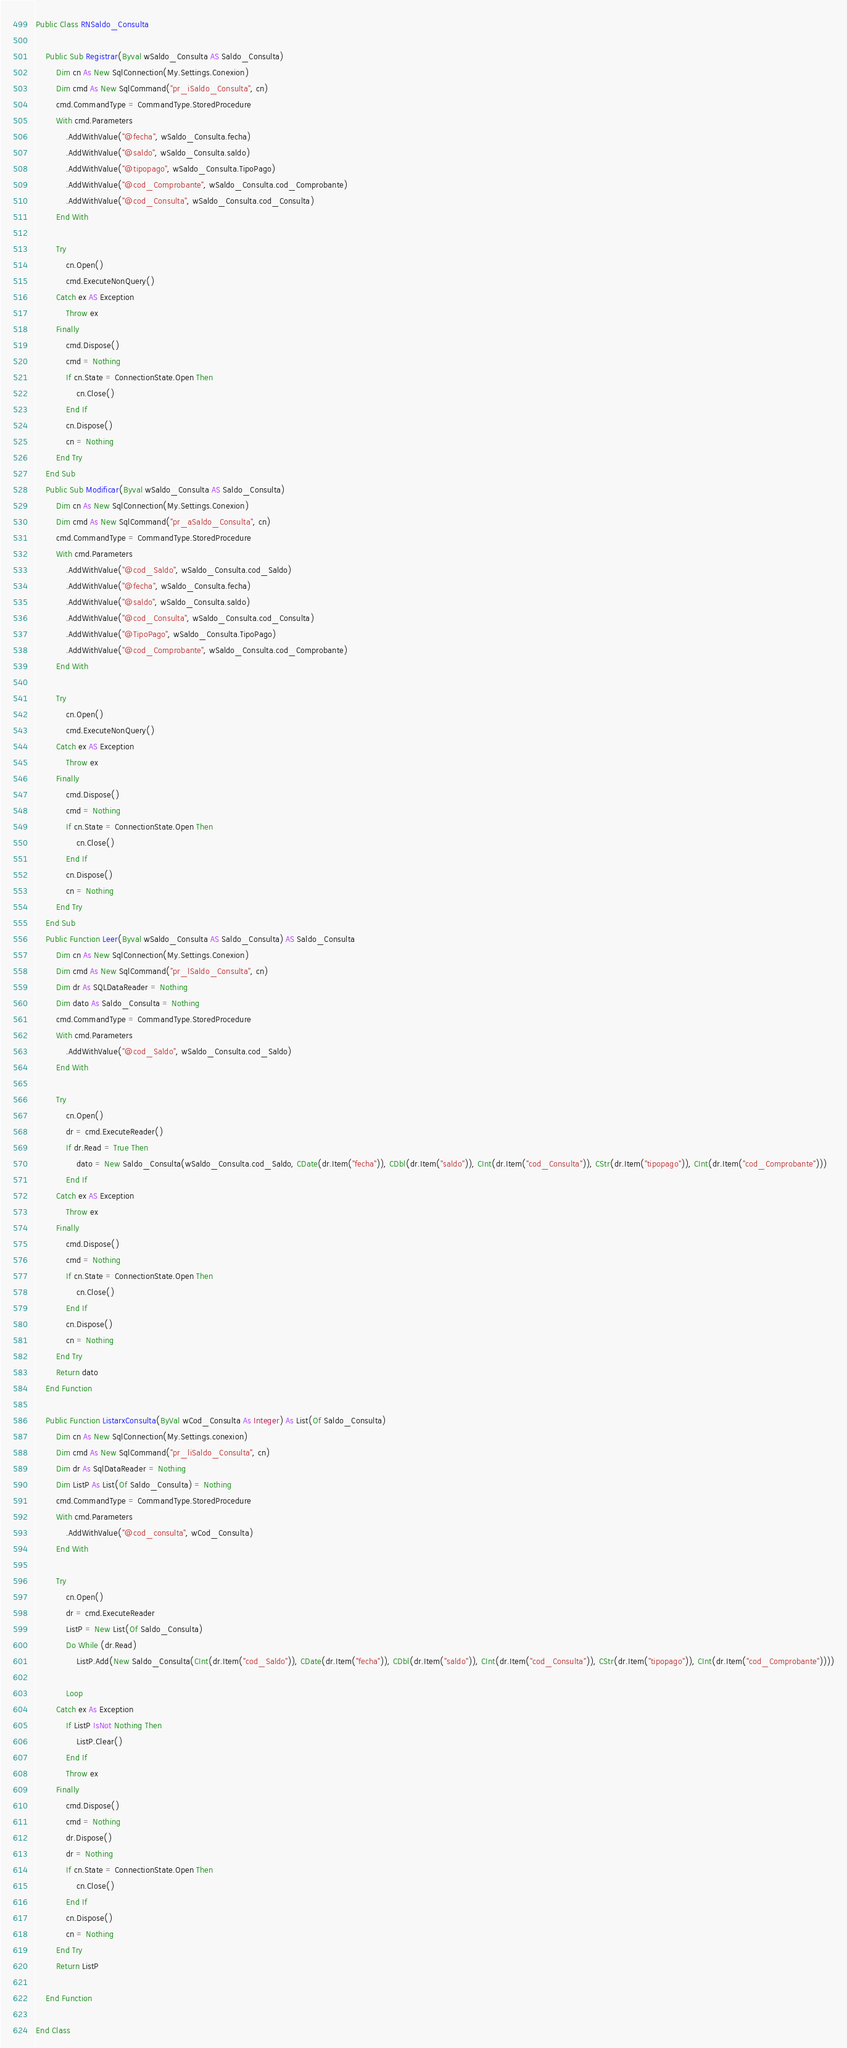<code> <loc_0><loc_0><loc_500><loc_500><_VisualBasic_>Public Class RNSaldo_Consulta

	Public Sub Registrar(Byval wSaldo_Consulta AS Saldo_Consulta)
		Dim cn As New SqlConnection(My.Settings.Conexion)
		Dim cmd As New SqlCommand("pr_iSaldo_Consulta", cn)
		cmd.CommandType = CommandType.StoredProcedure
		With cmd.Parameters
			.AddWithValue("@fecha", wSaldo_Consulta.fecha)
            .AddWithValue("@saldo", wSaldo_Consulta.saldo)
            .AddWithValue("@tipopago", wSaldo_Consulta.TipoPago)
            .AddWithValue("@cod_Comprobante", wSaldo_Consulta.cod_Comprobante)
            .AddWithValue("@cod_Consulta", wSaldo_Consulta.cod_Consulta)
		End With

		Try
			cn.Open()
			cmd.ExecuteNonQuery()
		Catch ex AS Exception
			Throw ex
		Finally
			cmd.Dispose()
			cmd = Nothing
			If cn.State = ConnectionState.Open Then
				cn.Close()
			End If
			cn.Dispose()
			cn = Nothing
		End Try
	End Sub
	Public Sub Modificar(Byval wSaldo_Consulta AS Saldo_Consulta)
		Dim cn As New SqlConnection(My.Settings.Conexion)
		Dim cmd As New SqlCommand("pr_aSaldo_Consulta", cn)
		cmd.CommandType = CommandType.StoredProcedure
		With cmd.Parameters
            .AddWithValue("@cod_Saldo", wSaldo_Consulta.cod_Saldo)
            .AddWithValue("@fecha", wSaldo_Consulta.fecha)
            .AddWithValue("@saldo", wSaldo_Consulta.saldo)
            .AddWithValue("@cod_Consulta", wSaldo_Consulta.cod_Consulta)
            .AddWithValue("@TipoPago", wSaldo_Consulta.TipoPago)
            .AddWithValue("@cod_Comprobante", wSaldo_Consulta.cod_Comprobante)
        End With

		Try
			cn.Open()
			cmd.ExecuteNonQuery()
		Catch ex AS Exception
			Throw ex
		Finally
			cmd.Dispose()
			cmd = Nothing
			If cn.State = ConnectionState.Open Then
				cn.Close()
			End If
			cn.Dispose()
			cn = Nothing
		End Try
	End Sub
	Public Function Leer(Byval wSaldo_Consulta AS Saldo_Consulta) AS Saldo_Consulta
		Dim cn As New SqlConnection(My.Settings.Conexion)
		Dim cmd As New SqlCommand("pr_lSaldo_Consulta", cn)
		Dim dr As SQLDataReader = Nothing
		Dim dato As Saldo_Consulta = Nothing
		cmd.CommandType = CommandType.StoredProcedure
		With cmd.Parameters
			.AddWithValue("@cod_Saldo", wSaldo_Consulta.cod_Saldo)
		End With

		Try
			cn.Open()
			dr = cmd.ExecuteReader()
			If dr.Read = True Then
                dato = New Saldo_Consulta(wSaldo_Consulta.cod_Saldo, CDate(dr.Item("fecha")), CDbl(dr.Item("saldo")), CInt(dr.Item("cod_Consulta")), CStr(dr.Item("tipopago")), CInt(dr.Item("cod_Comprobante")))
			End If
		Catch ex AS Exception
			Throw ex
		Finally
			cmd.Dispose()
			cmd = Nothing
			If cn.State = ConnectionState.Open Then
				cn.Close()
			End If
			cn.Dispose()
			cn = Nothing
		End Try
		Return dato
	End Function

    Public Function ListarxConsulta(ByVal wCod_Consulta As Integer) As List(Of Saldo_Consulta)
        Dim cn As New SqlConnection(My.Settings.conexion)
        Dim cmd As New SqlCommand("pr_liSaldo_Consulta", cn)
        Dim dr As SqlDataReader = Nothing
        Dim ListP As List(Of Saldo_Consulta) = Nothing
        cmd.CommandType = CommandType.StoredProcedure
        With cmd.Parameters
            .AddWithValue("@cod_consulta", wCod_Consulta)
        End With

        Try
            cn.Open()
            dr = cmd.ExecuteReader
            ListP = New List(Of Saldo_Consulta)
            Do While (dr.Read)
                ListP.Add(New Saldo_Consulta(CInt(dr.Item("cod_Saldo")), CDate(dr.Item("fecha")), CDbl(dr.Item("saldo")), CInt(dr.Item("cod_Consulta")), CStr(dr.Item("tipopago")), CInt(dr.Item("cod_Comprobante"))))
 
            Loop
        Catch ex As Exception
            If ListP IsNot Nothing Then
                ListP.Clear()
            End If
            Throw ex
        Finally
            cmd.Dispose()
            cmd = Nothing
            dr.Dispose()
            dr = Nothing
            If cn.State = ConnectionState.Open Then
                cn.Close()
            End If
            cn.Dispose()
            cn = Nothing
        End Try
        Return ListP

    End Function

End Class</code> 